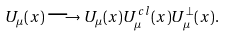Convert formula to latex. <formula><loc_0><loc_0><loc_500><loc_500>U _ { \mu } ( x ) \longrightarrow U _ { \mu } ( x ) U ^ { c l } _ { \mu } ( x ) U ^ { \perp } _ { \mu } ( x ) .</formula> 